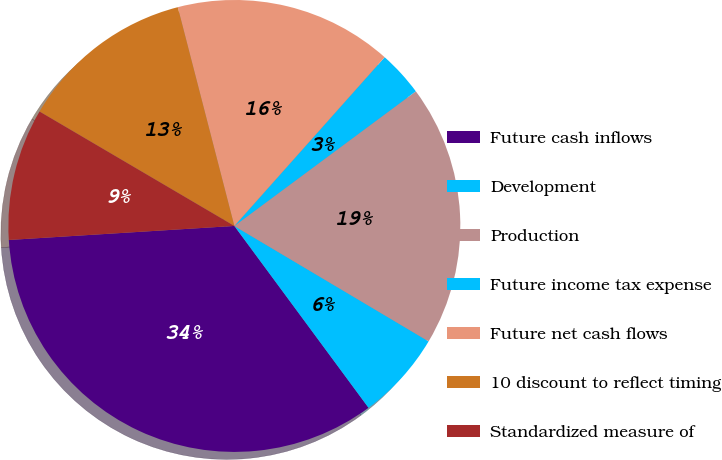Convert chart to OTSL. <chart><loc_0><loc_0><loc_500><loc_500><pie_chart><fcel>Future cash inflows<fcel>Development<fcel>Production<fcel>Future income tax expense<fcel>Future net cash flows<fcel>10 discount to reflect timing<fcel>Standardized measure of<nl><fcel>34.13%<fcel>6.35%<fcel>18.69%<fcel>3.26%<fcel>15.61%<fcel>12.52%<fcel>9.44%<nl></chart> 